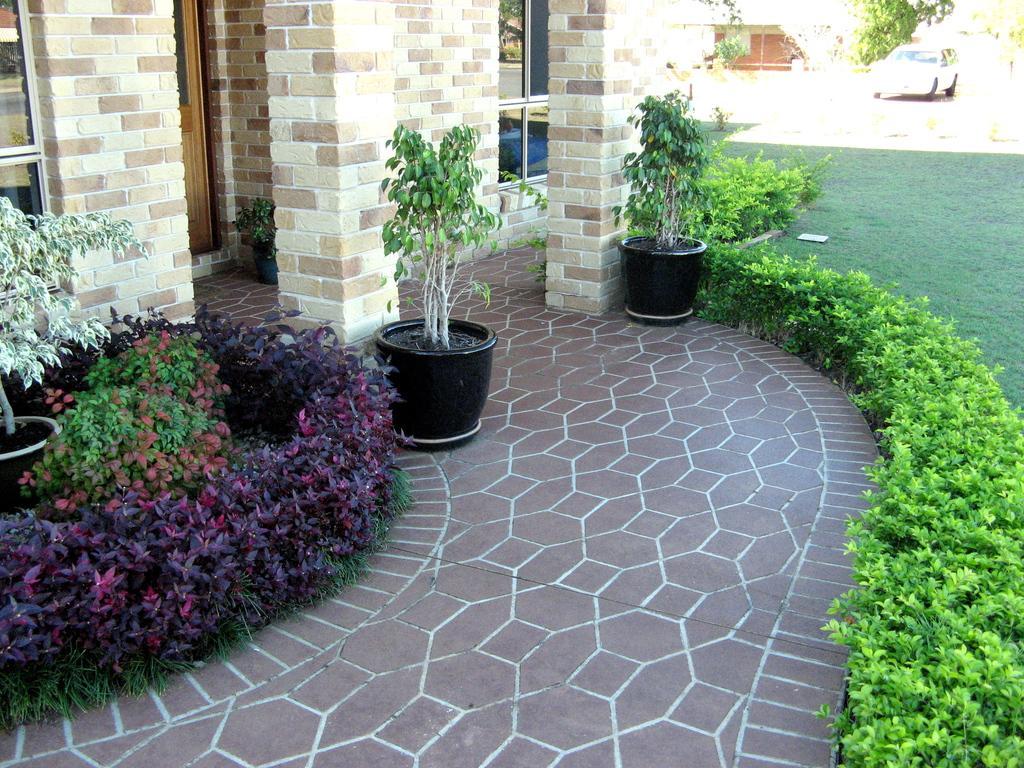In one or two sentences, can you explain what this image depicts? This is a picture of a house. In the foreground of the picture there are plants, grass, pavement, brick wall, windows and door. On the right there is a vehicle and grass. In the background there are trees and house. 